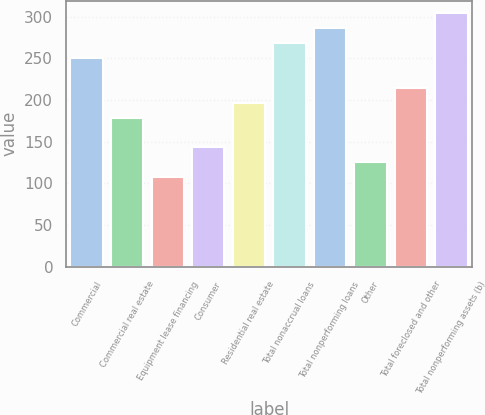<chart> <loc_0><loc_0><loc_500><loc_500><bar_chart><fcel>Commercial<fcel>Commercial real estate<fcel>Equipment lease financing<fcel>Consumer<fcel>Residential real estate<fcel>Total nonaccrual loans<fcel>Total nonperforming loans<fcel>Other<fcel>Total foreclosed and other<fcel>Total nonperforming assets (b)<nl><fcel>250.58<fcel>179.02<fcel>107.46<fcel>143.24<fcel>196.91<fcel>268.47<fcel>286.36<fcel>125.35<fcel>214.8<fcel>304.25<nl></chart> 